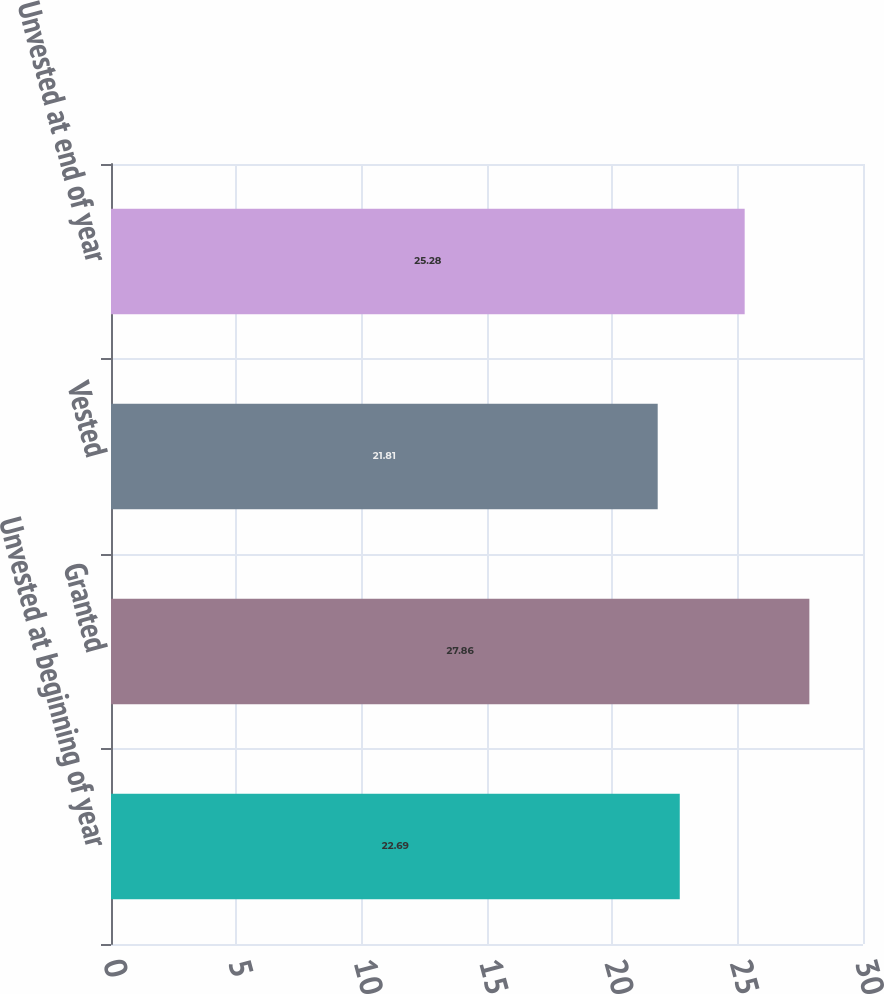<chart> <loc_0><loc_0><loc_500><loc_500><bar_chart><fcel>Unvested at beginning of year<fcel>Granted<fcel>Vested<fcel>Unvested at end of year<nl><fcel>22.69<fcel>27.86<fcel>21.81<fcel>25.28<nl></chart> 